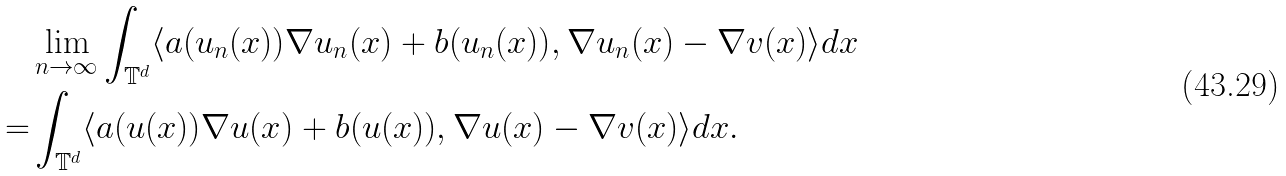<formula> <loc_0><loc_0><loc_500><loc_500>& \lim _ { n \rightarrow \infty } \int _ { \mathbb { T } ^ { d } } \langle a ( u _ { n } ( x ) ) \nabla u _ { n } ( x ) + b ( u _ { n } ( x ) ) , \nabla u _ { n } ( x ) - \nabla v ( x ) \rangle d x \\ = & \int _ { \mathbb { T } ^ { d } } \langle a ( u ( x ) ) \nabla u ( x ) + b ( u ( x ) ) , \nabla u ( x ) - \nabla v ( x ) \rangle d x .</formula> 